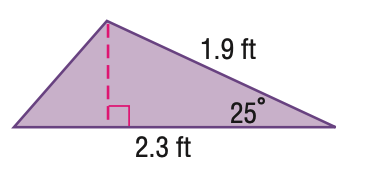Question: Find the area of the triangle. Round to the nearest hundredth.
Choices:
A. 0.92
B. 0.99
C. 1.02
D. 1.98
Answer with the letter. Answer: A 